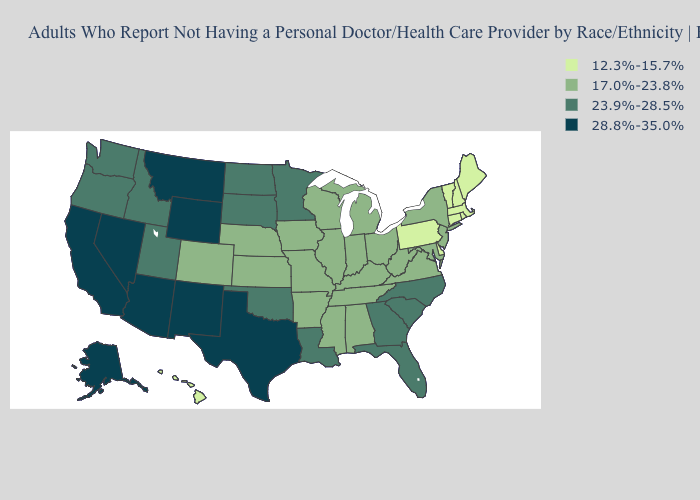Does Georgia have the highest value in the South?
Give a very brief answer. No. Among the states that border Delaware , which have the lowest value?
Quick response, please. Pennsylvania. Does Montana have the highest value in the USA?
Concise answer only. Yes. What is the value of Kentucky?
Be succinct. 17.0%-23.8%. Name the states that have a value in the range 28.8%-35.0%?
Write a very short answer. Alaska, Arizona, California, Montana, Nevada, New Mexico, Texas, Wyoming. What is the value of North Dakota?
Quick response, please. 23.9%-28.5%. Name the states that have a value in the range 28.8%-35.0%?
Be succinct. Alaska, Arizona, California, Montana, Nevada, New Mexico, Texas, Wyoming. What is the value of Alabama?
Answer briefly. 17.0%-23.8%. Does New Hampshire have the lowest value in the USA?
Short answer required. Yes. Does New Mexico have the highest value in the West?
Be succinct. Yes. Name the states that have a value in the range 23.9%-28.5%?
Be succinct. Florida, Georgia, Idaho, Louisiana, Minnesota, North Carolina, North Dakota, Oklahoma, Oregon, South Carolina, South Dakota, Utah, Washington. What is the highest value in the USA?
Short answer required. 28.8%-35.0%. Is the legend a continuous bar?
Give a very brief answer. No. How many symbols are there in the legend?
Write a very short answer. 4. Which states have the lowest value in the USA?
Answer briefly. Connecticut, Delaware, Hawaii, Maine, Massachusetts, New Hampshire, Pennsylvania, Rhode Island, Vermont. 